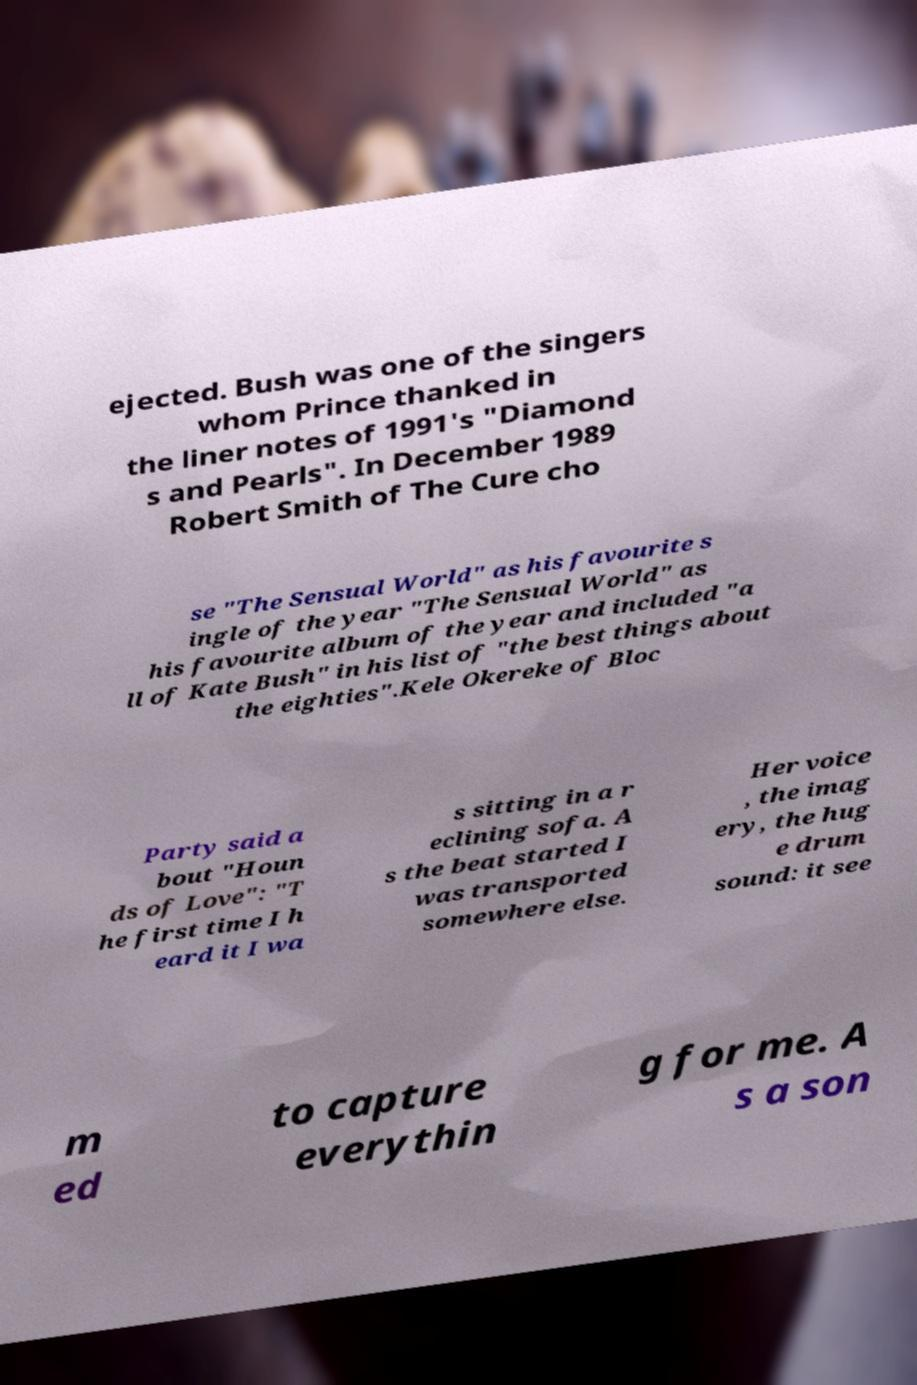Can you accurately transcribe the text from the provided image for me? ejected. Bush was one of the singers whom Prince thanked in the liner notes of 1991's "Diamond s and Pearls". In December 1989 Robert Smith of The Cure cho se "The Sensual World" as his favourite s ingle of the year "The Sensual World" as his favourite album of the year and included "a ll of Kate Bush" in his list of "the best things about the eighties".Kele Okereke of Bloc Party said a bout "Houn ds of Love": "T he first time I h eard it I wa s sitting in a r eclining sofa. A s the beat started I was transported somewhere else. Her voice , the imag ery, the hug e drum sound: it see m ed to capture everythin g for me. A s a son 